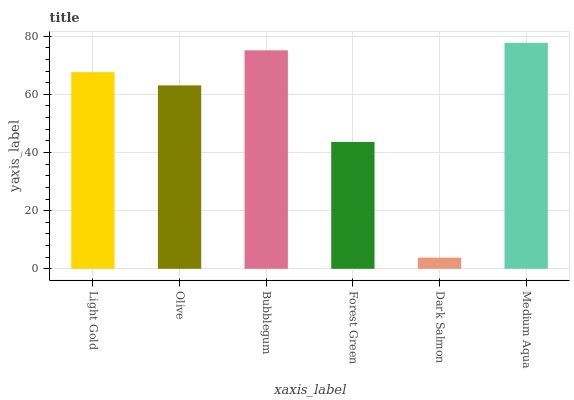Is Olive the minimum?
Answer yes or no. No. Is Olive the maximum?
Answer yes or no. No. Is Light Gold greater than Olive?
Answer yes or no. Yes. Is Olive less than Light Gold?
Answer yes or no. Yes. Is Olive greater than Light Gold?
Answer yes or no. No. Is Light Gold less than Olive?
Answer yes or no. No. Is Light Gold the high median?
Answer yes or no. Yes. Is Olive the low median?
Answer yes or no. Yes. Is Olive the high median?
Answer yes or no. No. Is Forest Green the low median?
Answer yes or no. No. 